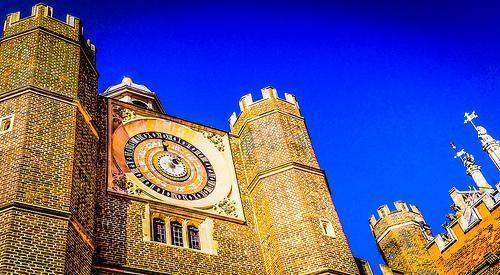How many people standing on the roof?
Give a very brief answer. 0. 